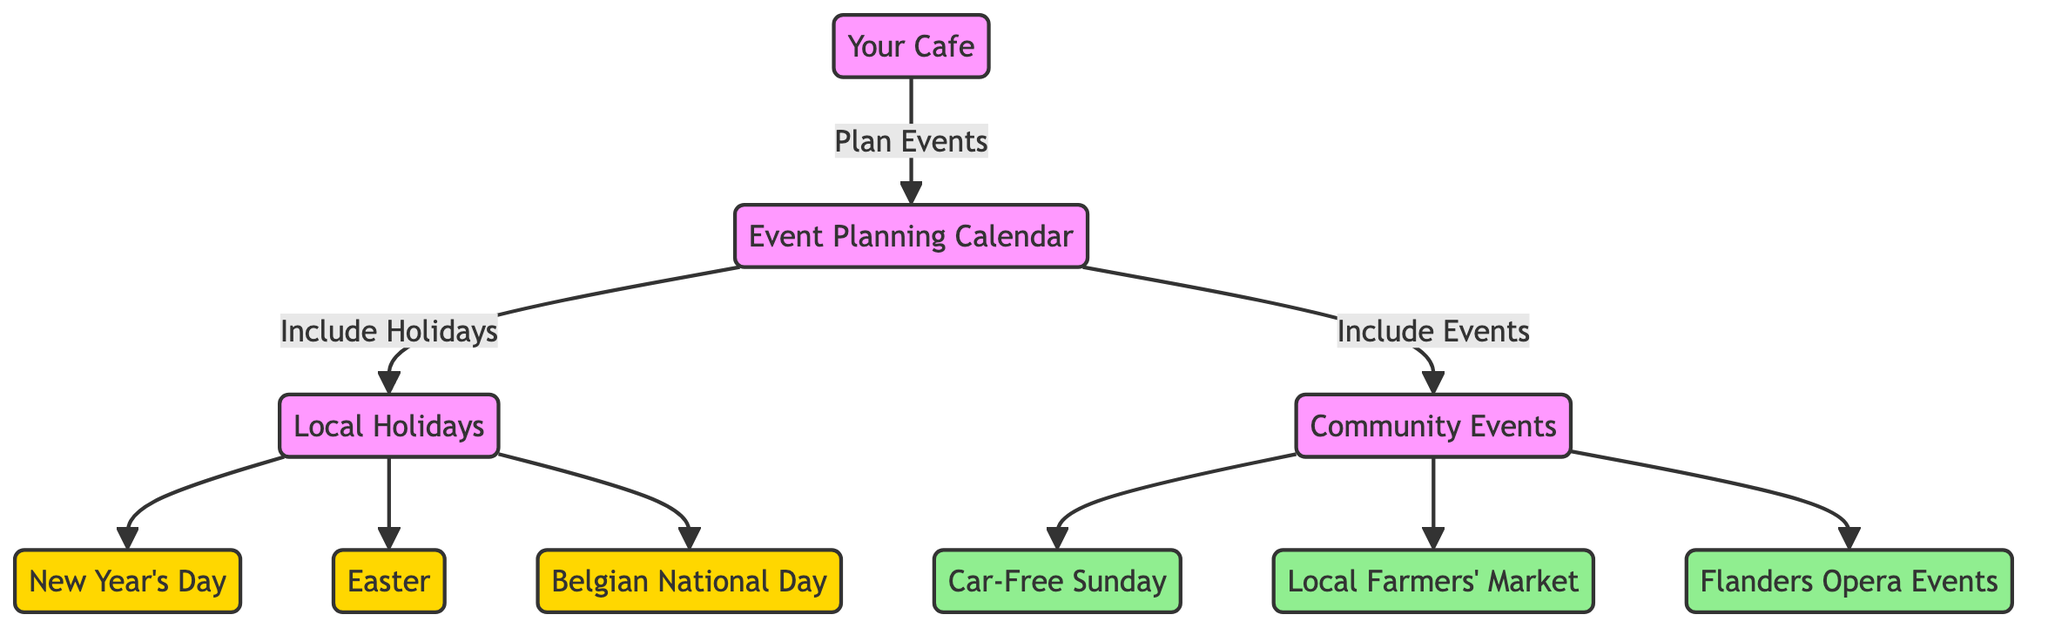What is the main purpose of the event planning calendar? The event planning calendar's primary purpose is to facilitate the planning of events at your cafe by including both local holidays and community events.
Answer: Facilitate event planning How many local holidays are listed in the diagram? There are three local holidays (New Year's Day, Easter, and Belgian National Day) shown in the diagram. Therefore, we count those nodes.
Answer: Three Which event is associated with the community category? The events under the community category include Car-Free Sunday, Local Farmers' Market, and Flanders Opera Events. This confirms they are linked to the community events node.
Answer: Car-Free Sunday What color represents community events in the diagram? The community events are highlighted with a light green color (hex code #90ee90) according to the classes designated in the diagram.
Answer: Light green Which local holiday comes first in the chronological order? New Year's Day is the first holiday chronologically as it occurs on January 1st, which comes before Easter and Belgian National Day.
Answer: New Year's Day How are community events related to the event planning calendar? Community events are directly connected to the event planning calendar, indicating that they should be included in the event planning process as shown in the diagram.
Answer: Included in event planning Which visual element indicates local holidays in the diagram? Local holidays are represented by a golden yellow color (hex code #ffd700), which visually distinguishes them from other elements in the diagram.
Answer: Golden yellow What type of diagram is being used? The diagram is identified as a flowchart, indicating the pathways and connections between the various elements of event planning.
Answer: Flowchart 